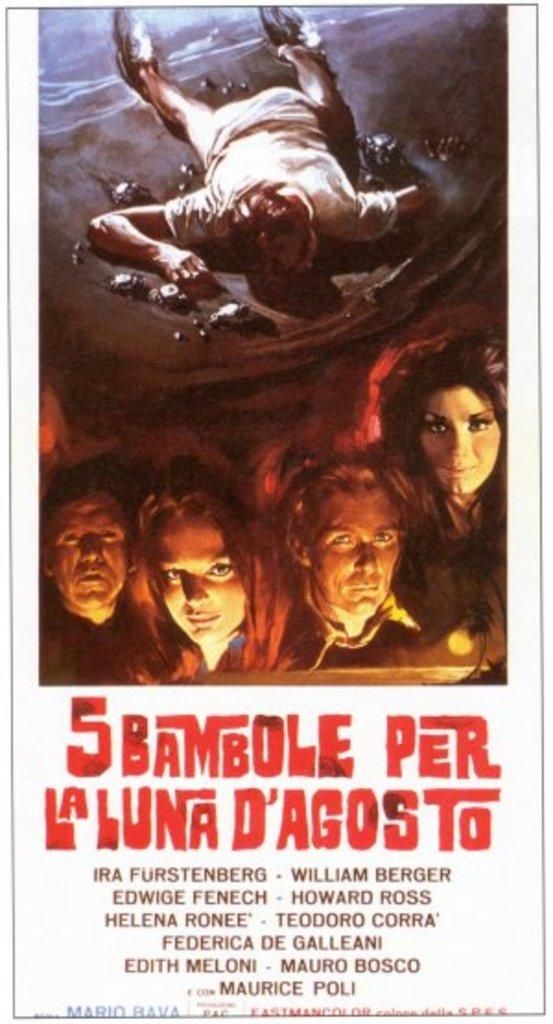<image>
Relay a brief, clear account of the picture shown. A movie poster for 5 Bambole Per La Luna D'Agosto. 